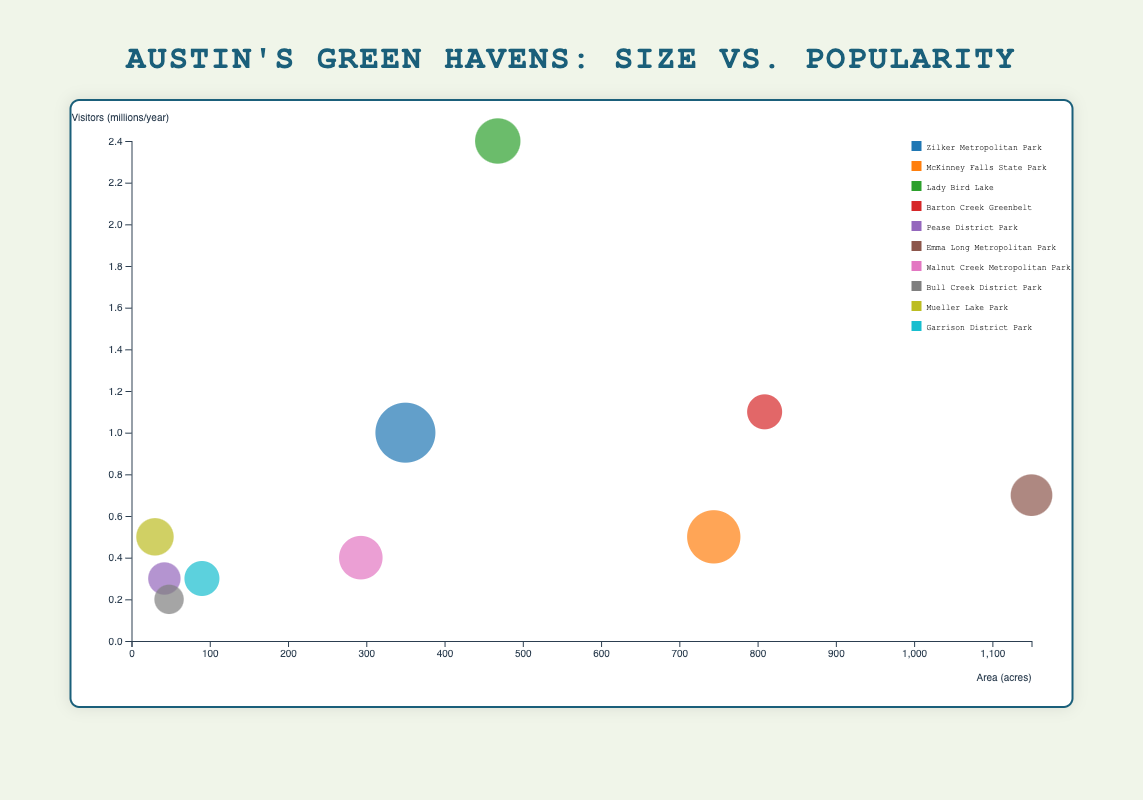What's the title of the chart? The title of the chart is usually located at the top of the chart. In this case, it is "Austin's Green Havens: Size vs. Popularity".
Answer: Austin's Green Havens: Size vs. Popularity Which park has the largest area in acres? By examining the bubble chart, the park with the largest area corresponds to the largest x-axis value. "Emma Long Metropolitan Park" has an area of 1150 acres, which is the maximum.
Answer: Emma Long Metropolitan Park How many parks have fewer than 0.5 million visitors per year? Looking at the y-axis values in the bubble chart and counting the parks with less than 0.5 million visitors, we find "Bull Creek District Park," "Pease District Park," "Garrison District Park," "Walnut Creek Metropolitan Park," and "McKinney Falls State Park." This totals 5 parks.
Answer: 5 What's the average number of facilities across all parks? To find the average number of facilities, we sum the number of facilities and divide by the total number of parks: (20 + 15 + 10 + 5 + 4 + 8 + 9 + 3 + 6 + 5) / 10 = 85 / 10 = 8.5.
Answer: 8.5 Which park has the highest number of visitors per year, and how many visitors does it have? On the y-axis, the park with the highest value is "Lady Bird Lake" which reaches up to 2.4 million visitors per year.
Answer: Lady Bird Lake, 2.4 million Compare the area of Barton Creek Greenbelt and Zilker Metropolitan Park. Which one is larger and by how much? From the chart, "Barton Creek Greenbelt" covers 809 acres and "Zilker Metropolitan Park" covers 350 acres. The difference is 809 - 350 = 459 acres.
Answer: Barton Creek Greenbelt, 459 acres What's the total number of visitors for parks that have more than 10 facilities? The parks with more than 10 facilities are "Zilker Metropolitan Park" (1 million visitors) and "McKinney Falls State Park" (0.5 million visitors). Adding these gives 1 + 0.5 = 1.5 million visitors.
Answer: 1.5 million Which park has the smallest bubble, and how many facilities does it have? The smallest bubble corresponds to the park with the fewest facilities. In this context, "Bull Creek District Park" has a bubble indicating it has 3 facilities.
Answer: Bull Creek District Park, 3 facilities How many parks have an area between 100 and 500 acres? By identifying the parks on the x-axis which fall between these values, we see "Zilker Metropolitan Park", "Lady Bird Lake", "Walnut Creek Metropolitan Park", "McKinney Falls State Park". This includes 4 parks.
Answer: 4 